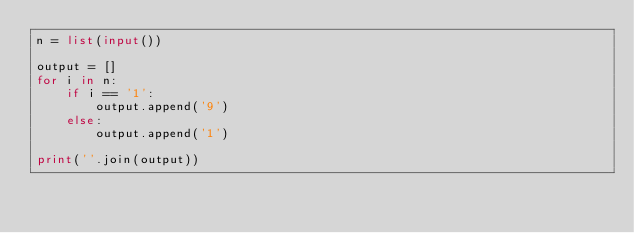Convert code to text. <code><loc_0><loc_0><loc_500><loc_500><_Python_>n = list(input())

output = []
for i in n:
    if i == '1':
        output.append('9')
    else:
        output.append('1')

print(''.join(output))</code> 